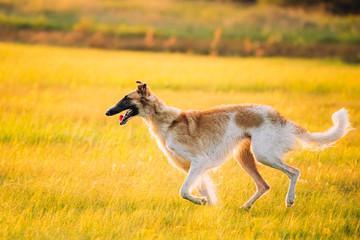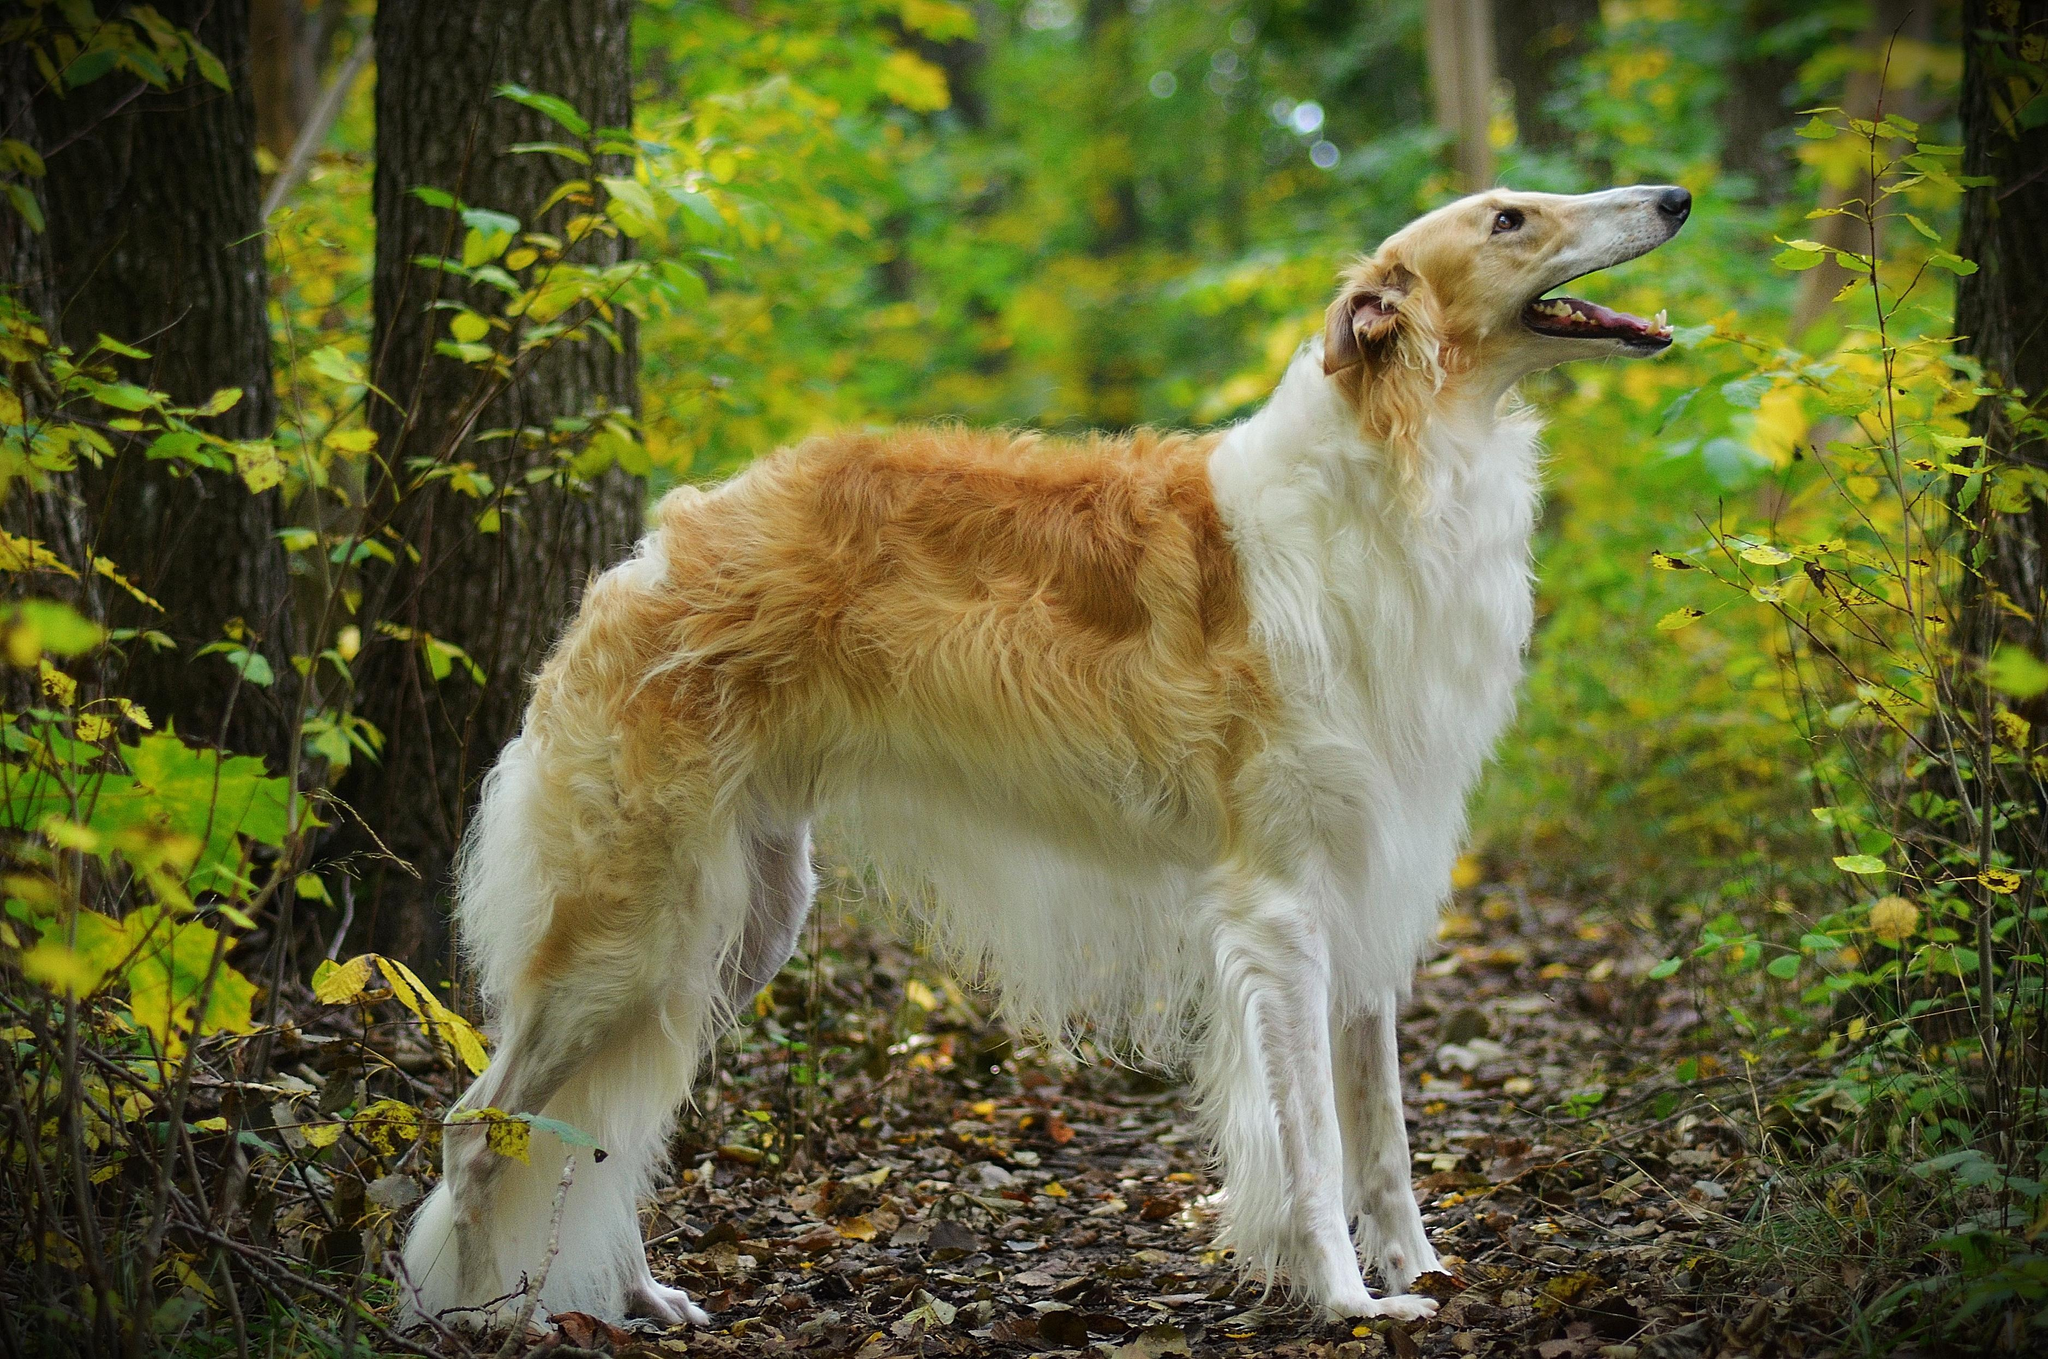The first image is the image on the left, the second image is the image on the right. For the images shown, is this caption "At least one dog wears a collar with no leash." true? Answer yes or no. No. 